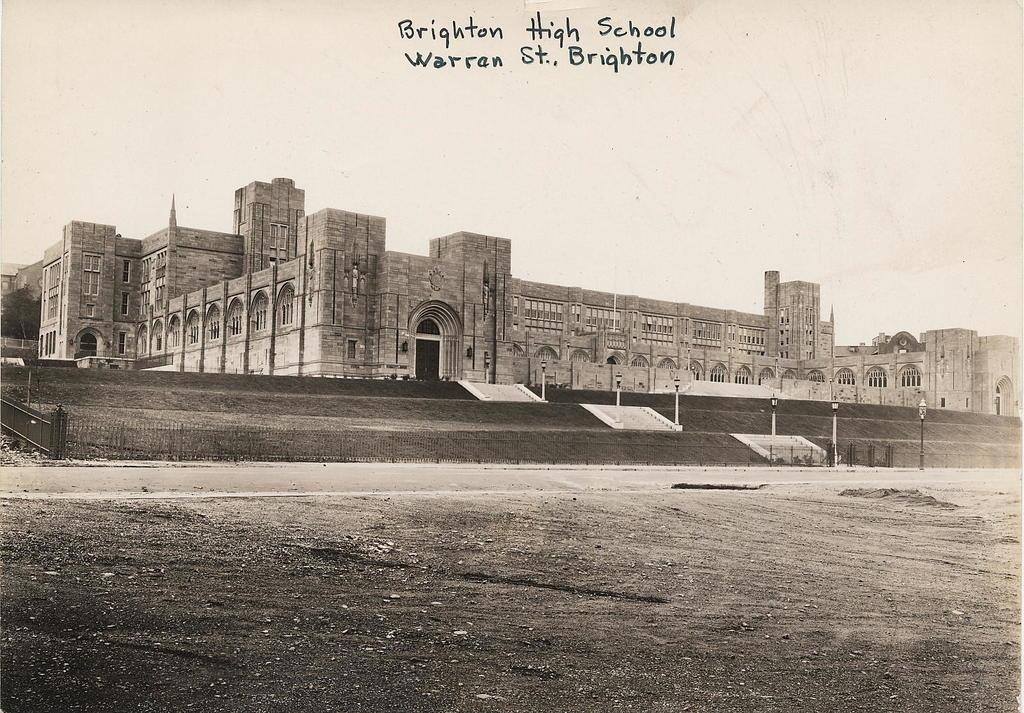Provide a one-sentence caption for the provided image. A black and white photograph of a multi-story building with a writing that reads Brighton High School Warren St., Brighten. 